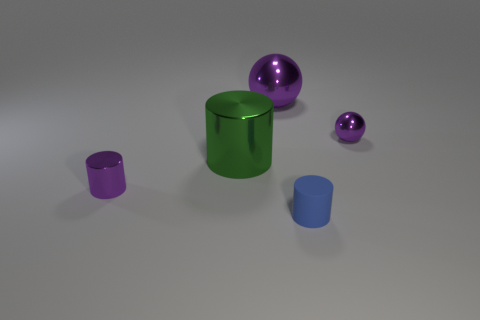How many balls are green objects or big yellow rubber objects?
Your response must be concise. 0. The other purple cylinder that is the same material as the big cylinder is what size?
Make the answer very short. Small. What number of tiny shiny balls are the same color as the small metallic cylinder?
Offer a very short reply. 1. Are there any metal cylinders on the right side of the large shiny sphere?
Provide a short and direct response. No. There is a blue object; is it the same shape as the tiny shiny thing that is right of the tiny blue matte cylinder?
Make the answer very short. No. How many things are objects on the left side of the green metallic cylinder or purple metal cylinders?
Offer a very short reply. 1. Are there any other things that are the same material as the blue cylinder?
Keep it short and to the point. No. How many things are both in front of the green shiny object and on the left side of the tiny blue object?
Make the answer very short. 1. How many things are purple shiny spheres to the right of the large ball or small metallic things to the right of the green cylinder?
Keep it short and to the point. 1. How many other objects are there of the same shape as the large green object?
Offer a very short reply. 2. 